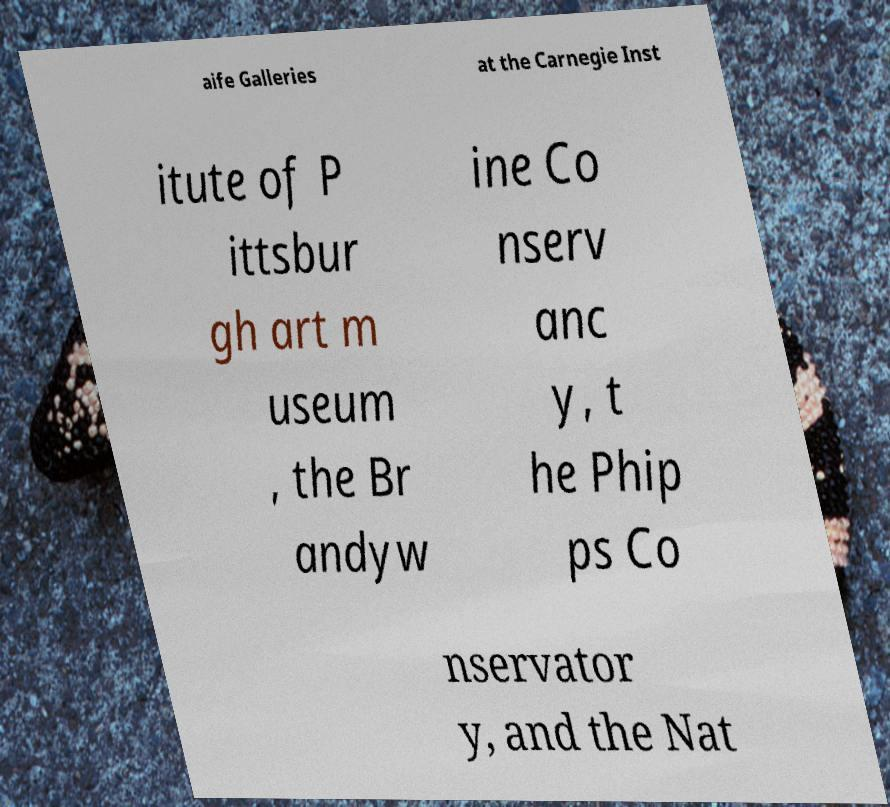I need the written content from this picture converted into text. Can you do that? aife Galleries at the Carnegie Inst itute of P ittsbur gh art m useum , the Br andyw ine Co nserv anc y, t he Phip ps Co nservator y, and the Nat 